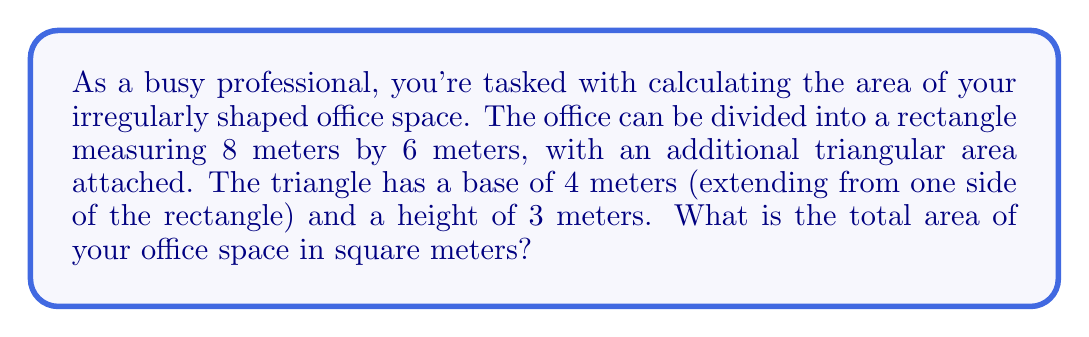Provide a solution to this math problem. Let's break this down step-by-step:

1. Calculate the area of the rectangular part:
   $$A_{rectangle} = length \times width$$
   $$A_{rectangle} = 8 \text{ m} \times 6 \text{ m} = 48 \text{ m}^2$$

2. Calculate the area of the triangular part:
   $$A_{triangle} = \frac{1}{2} \times base \times height$$
   $$A_{triangle} = \frac{1}{2} \times 4 \text{ m} \times 3 \text{ m} = 6 \text{ m}^2$$

3. Sum up the areas to get the total office space:
   $$A_{total} = A_{rectangle} + A_{triangle}$$
   $$A_{total} = 48 \text{ m}^2 + 6 \text{ m}^2 = 54 \text{ m}^2$$

[asy]
unitsize(1cm);
draw((0,0)--(8,0)--(8,6)--(0,6)--cycle);
draw((8,0)--(12,0)--(8,3)--cycle);
label("8 m", (4,0), S);
label("6 m", (0,3), W);
label("4 m", (10,0), S);
label("3 m", (10,1.5), E);
[/asy]
Answer: 54 m² 